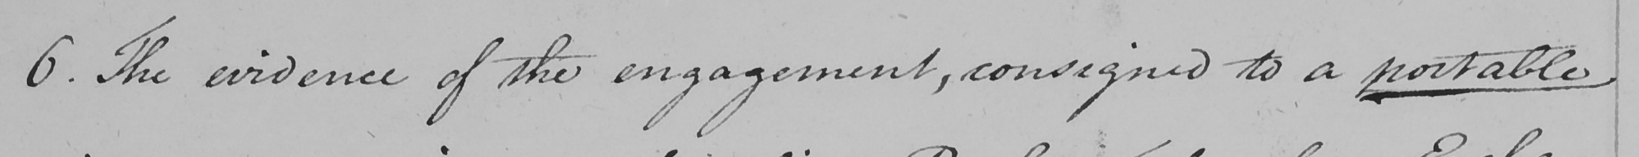Can you tell me what this handwritten text says? 6 . The evidence of the engagement , consigned to a portable 